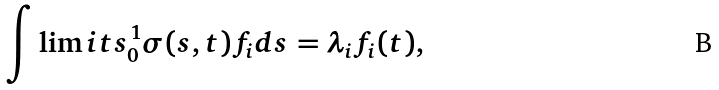Convert formula to latex. <formula><loc_0><loc_0><loc_500><loc_500>\int \lim i t s _ { 0 } ^ { 1 } { \sigma ( s , t ) f _ { i } d s = \lambda _ { i } f _ { i } ( t ) } ,</formula> 